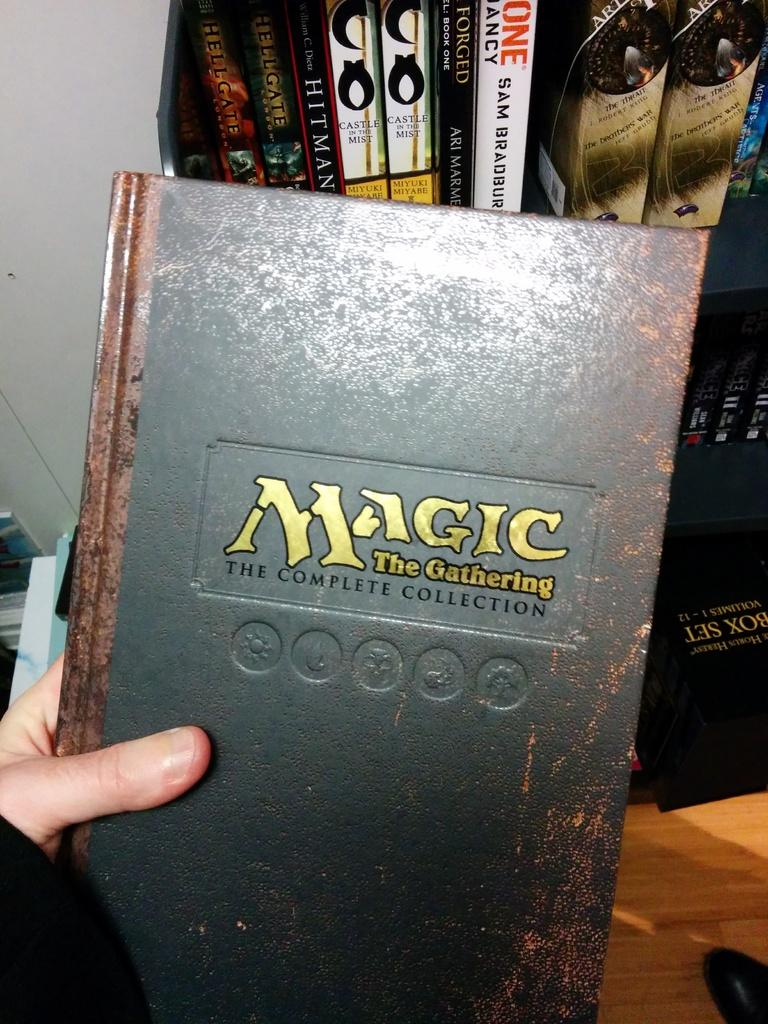<image>
Give a short and clear explanation of the subsequent image. A grey book with the title "Magic: The gathering". 